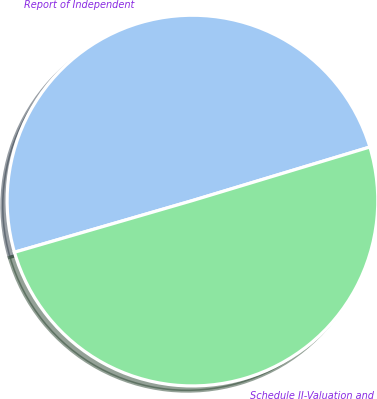Convert chart. <chart><loc_0><loc_0><loc_500><loc_500><pie_chart><fcel>Report of Independent<fcel>Schedule II-Valuation and<nl><fcel>49.83%<fcel>50.17%<nl></chart> 